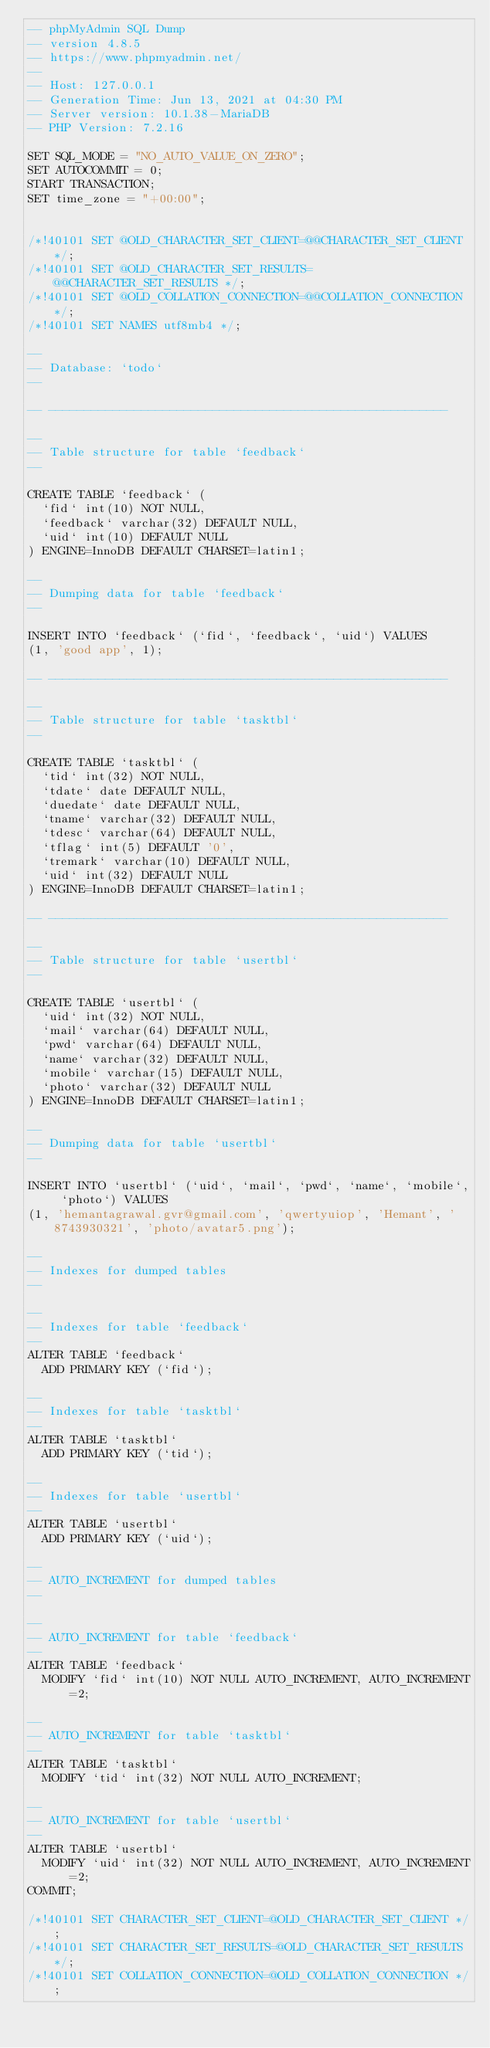<code> <loc_0><loc_0><loc_500><loc_500><_SQL_>-- phpMyAdmin SQL Dump
-- version 4.8.5
-- https://www.phpmyadmin.net/
--
-- Host: 127.0.0.1
-- Generation Time: Jun 13, 2021 at 04:30 PM
-- Server version: 10.1.38-MariaDB
-- PHP Version: 7.2.16

SET SQL_MODE = "NO_AUTO_VALUE_ON_ZERO";
SET AUTOCOMMIT = 0;
START TRANSACTION;
SET time_zone = "+00:00";


/*!40101 SET @OLD_CHARACTER_SET_CLIENT=@@CHARACTER_SET_CLIENT */;
/*!40101 SET @OLD_CHARACTER_SET_RESULTS=@@CHARACTER_SET_RESULTS */;
/*!40101 SET @OLD_COLLATION_CONNECTION=@@COLLATION_CONNECTION */;
/*!40101 SET NAMES utf8mb4 */;

--
-- Database: `todo`
--

-- --------------------------------------------------------

--
-- Table structure for table `feedback`
--

CREATE TABLE `feedback` (
  `fid` int(10) NOT NULL,
  `feedback` varchar(32) DEFAULT NULL,
  `uid` int(10) DEFAULT NULL
) ENGINE=InnoDB DEFAULT CHARSET=latin1;

--
-- Dumping data for table `feedback`
--

INSERT INTO `feedback` (`fid`, `feedback`, `uid`) VALUES
(1, 'good app', 1);

-- --------------------------------------------------------

--
-- Table structure for table `tasktbl`
--

CREATE TABLE `tasktbl` (
  `tid` int(32) NOT NULL,
  `tdate` date DEFAULT NULL,
  `duedate` date DEFAULT NULL,
  `tname` varchar(32) DEFAULT NULL,
  `tdesc` varchar(64) DEFAULT NULL,
  `tflag` int(5) DEFAULT '0',
  `tremark` varchar(10) DEFAULT NULL,
  `uid` int(32) DEFAULT NULL
) ENGINE=InnoDB DEFAULT CHARSET=latin1;

-- --------------------------------------------------------

--
-- Table structure for table `usertbl`
--

CREATE TABLE `usertbl` (
  `uid` int(32) NOT NULL,
  `mail` varchar(64) DEFAULT NULL,
  `pwd` varchar(64) DEFAULT NULL,
  `name` varchar(32) DEFAULT NULL,
  `mobile` varchar(15) DEFAULT NULL,
  `photo` varchar(32) DEFAULT NULL
) ENGINE=InnoDB DEFAULT CHARSET=latin1;

--
-- Dumping data for table `usertbl`
--

INSERT INTO `usertbl` (`uid`, `mail`, `pwd`, `name`, `mobile`, `photo`) VALUES
(1, 'hemantagrawal.gvr@gmail.com', 'qwertyuiop', 'Hemant', '8743930321', 'photo/avatar5.png');

--
-- Indexes for dumped tables
--

--
-- Indexes for table `feedback`
--
ALTER TABLE `feedback`
  ADD PRIMARY KEY (`fid`);

--
-- Indexes for table `tasktbl`
--
ALTER TABLE `tasktbl`
  ADD PRIMARY KEY (`tid`);

--
-- Indexes for table `usertbl`
--
ALTER TABLE `usertbl`
  ADD PRIMARY KEY (`uid`);

--
-- AUTO_INCREMENT for dumped tables
--

--
-- AUTO_INCREMENT for table `feedback`
--
ALTER TABLE `feedback`
  MODIFY `fid` int(10) NOT NULL AUTO_INCREMENT, AUTO_INCREMENT=2;

--
-- AUTO_INCREMENT for table `tasktbl`
--
ALTER TABLE `tasktbl`
  MODIFY `tid` int(32) NOT NULL AUTO_INCREMENT;

--
-- AUTO_INCREMENT for table `usertbl`
--
ALTER TABLE `usertbl`
  MODIFY `uid` int(32) NOT NULL AUTO_INCREMENT, AUTO_INCREMENT=2;
COMMIT;

/*!40101 SET CHARACTER_SET_CLIENT=@OLD_CHARACTER_SET_CLIENT */;
/*!40101 SET CHARACTER_SET_RESULTS=@OLD_CHARACTER_SET_RESULTS */;
/*!40101 SET COLLATION_CONNECTION=@OLD_COLLATION_CONNECTION */;
</code> 